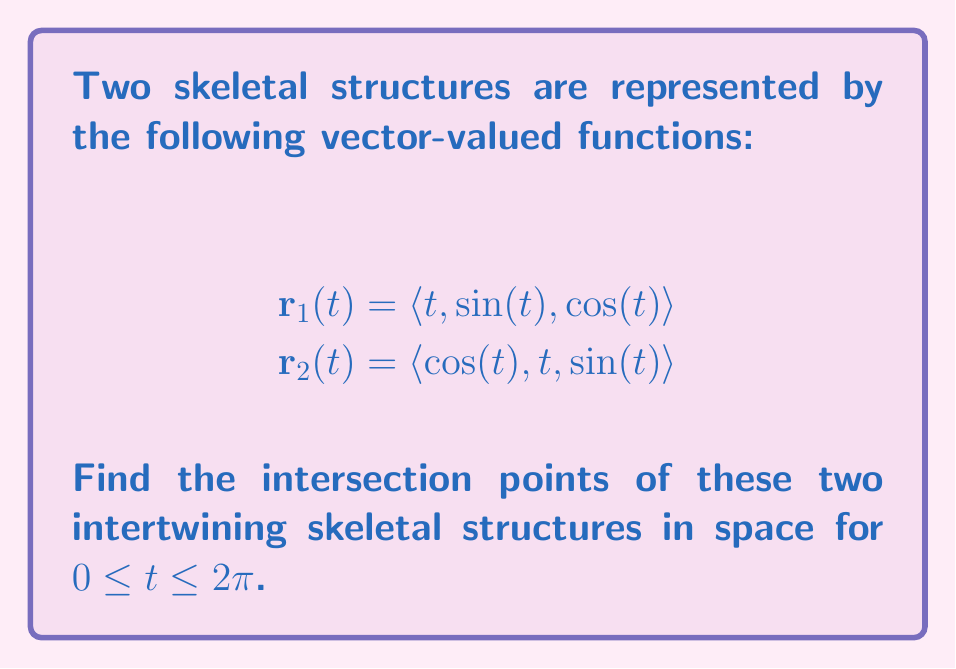What is the answer to this math problem? To find the intersection points, we need to equate the corresponding components of $\mathbf{r}_1(t)$ and $\mathbf{r}_2(t)$:

1) $t = \cos(t)$
2) $\sin(t) = t$
3) $\cos(t) = \sin(t)$

From equation 3, we know that $\cos(t) = \sin(t)$ occurs when $t = \frac{\pi}{4}$ and $t = \frac{5\pi}{4}$ in the given interval.

Let's check if these values satisfy the other two equations:

For $t = \frac{\pi}{4}$:
1) $\frac{\pi}{4} \approx 0.7854 \neq \cos(\frac{\pi}{4}) \approx 0.7071$
2) $\sin(\frac{\pi}{4}) \approx 0.7071 \neq \frac{\pi}{4} \approx 0.7854$

For $t = \frac{5\pi}{4}$:
1) $\frac{5\pi}{4} \approx 3.9270 \neq \cos(\frac{5\pi}{4}) \approx -0.7071$
2) $\sin(\frac{5\pi}{4}) \approx -0.7071 \neq \frac{5\pi}{4} \approx 3.9270$

Neither of these points satisfies all three equations simultaneously. Therefore, we need to solve the system of equations numerically.

Using a numerical method (e.g., Newton-Raphson), we find that there are two intersection points in the given interval:

1) $t \approx 0.8603$
2) $t \approx 3.8584$

We can verify these points by substituting them back into the original vector-valued functions:

For $t \approx 0.8603$:
$$\mathbf{r}_1(0.8603) \approx \langle 0.8603, 0.7586, 0.6516 \rangle$$
$$\mathbf{r}_2(0.8603) \approx \langle 0.6516, 0.8603, 0.7586 \rangle$$

For $t \approx 3.8584$:
$$\mathbf{r}_1(3.8584) \approx \langle 3.8584, -0.7586, -0.6516 \rangle$$
$$\mathbf{r}_2(3.8584) \approx \langle -0.6516, 3.8584, -0.7586 \rangle$$
Answer: The two skeletal structures intersect at two points:
1) $\langle 0.8603, 0.7586, 0.6516 \rangle$
2) $\langle 3.8584, -0.7586, -0.6516 \rangle$ 